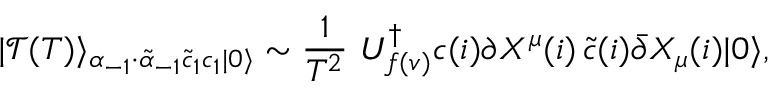Convert formula to latex. <formula><loc_0><loc_0><loc_500><loc_500>| \mathcal { T } ( T ) \rangle _ { \alpha _ { - 1 } \cdot \tilde { \alpha } _ { - 1 } \tilde { c } _ { 1 } c _ { 1 } | 0 \rangle } \sim \frac { 1 } { T ^ { 2 } } \, U _ { f ( v ) } ^ { \dagger } c ( i ) \partial X ^ { \mu } ( i ) \, \tilde { c } ( i ) \bar { \partial } X _ { \mu } ( i ) | 0 \rangle ,</formula> 